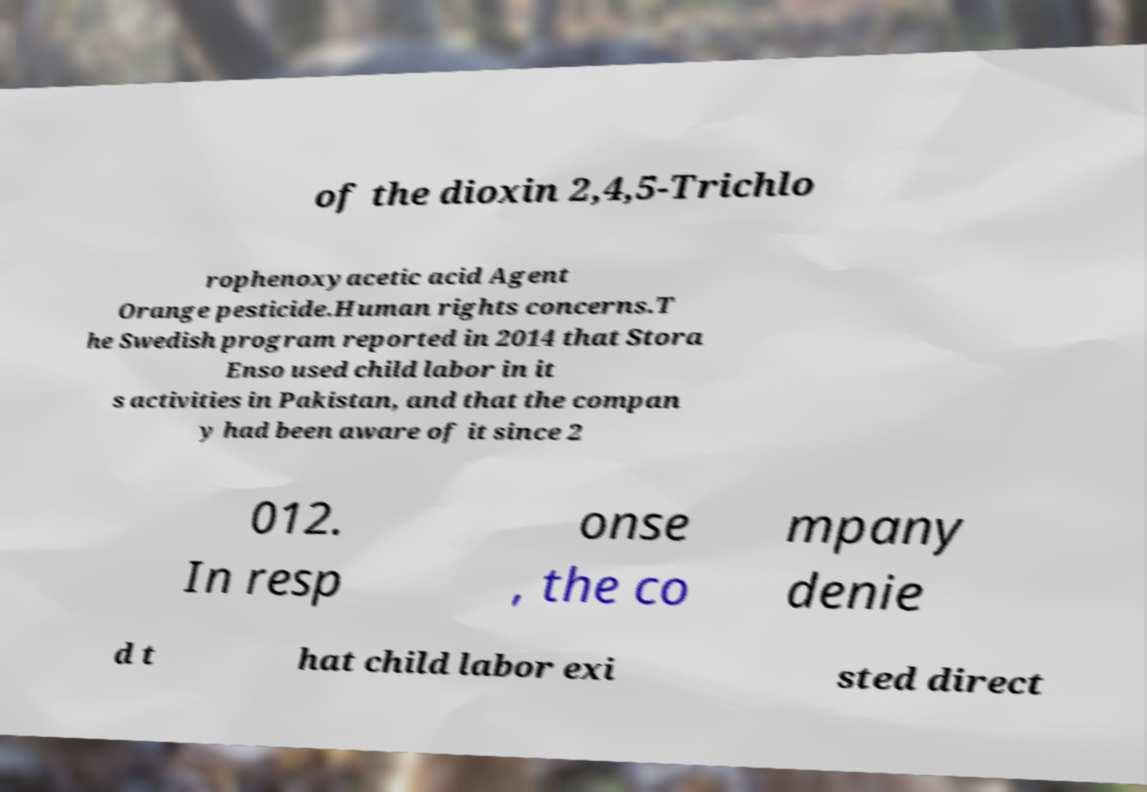Please read and relay the text visible in this image. What does it say? of the dioxin 2,4,5-Trichlo rophenoxyacetic acid Agent Orange pesticide.Human rights concerns.T he Swedish program reported in 2014 that Stora Enso used child labor in it s activities in Pakistan, and that the compan y had been aware of it since 2 012. In resp onse , the co mpany denie d t hat child labor exi sted direct 